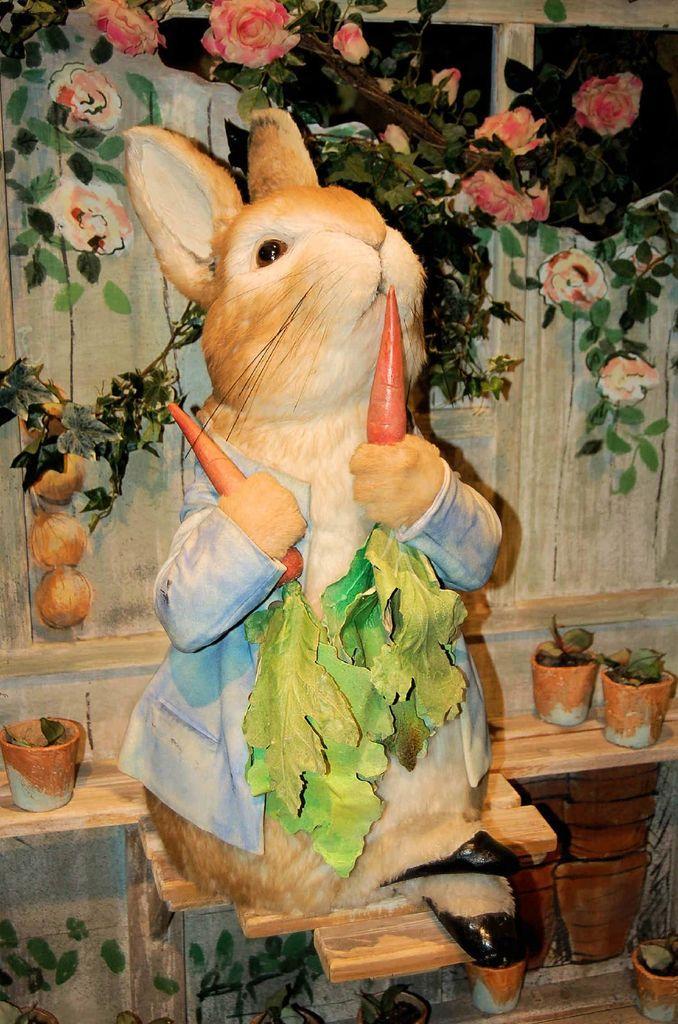Describe this image in one or two sentences. In this image we can see a rabbit, it is in brown color, and holding carrots in the hand, at back there are flower pots, there are plants, and flowers on it, at the back there is wooden wall. 